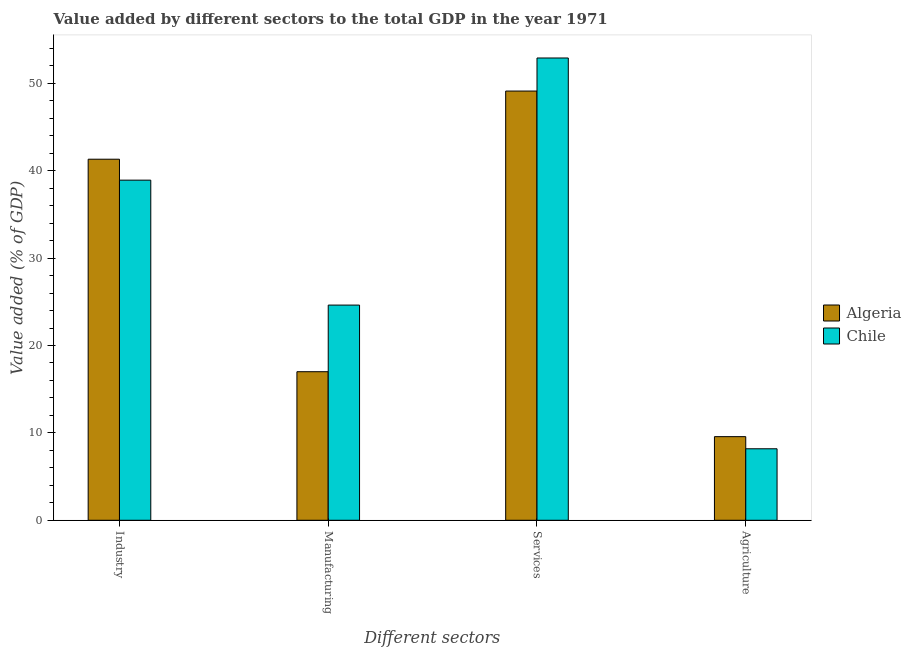How many groups of bars are there?
Ensure brevity in your answer.  4. Are the number of bars per tick equal to the number of legend labels?
Provide a succinct answer. Yes. What is the label of the 1st group of bars from the left?
Your response must be concise. Industry. What is the value added by agricultural sector in Chile?
Your response must be concise. 8.18. Across all countries, what is the maximum value added by manufacturing sector?
Offer a terse response. 24.62. Across all countries, what is the minimum value added by manufacturing sector?
Your answer should be compact. 17. In which country was the value added by industrial sector maximum?
Make the answer very short. Algeria. In which country was the value added by services sector minimum?
Your answer should be very brief. Algeria. What is the total value added by agricultural sector in the graph?
Your answer should be very brief. 17.75. What is the difference between the value added by agricultural sector in Chile and that in Algeria?
Make the answer very short. -1.39. What is the difference between the value added by services sector in Chile and the value added by agricultural sector in Algeria?
Give a very brief answer. 43.33. What is the average value added by industrial sector per country?
Ensure brevity in your answer.  40.12. What is the difference between the value added by services sector and value added by industrial sector in Chile?
Your answer should be very brief. 13.98. What is the ratio of the value added by industrial sector in Algeria to that in Chile?
Give a very brief answer. 1.06. What is the difference between the highest and the second highest value added by manufacturing sector?
Give a very brief answer. 7.62. What is the difference between the highest and the lowest value added by agricultural sector?
Provide a succinct answer. 1.39. In how many countries, is the value added by industrial sector greater than the average value added by industrial sector taken over all countries?
Your answer should be compact. 1. Is the sum of the value added by manufacturing sector in Chile and Algeria greater than the maximum value added by agricultural sector across all countries?
Your answer should be compact. Yes. What does the 1st bar from the left in Manufacturing represents?
Ensure brevity in your answer.  Algeria. What does the 1st bar from the right in Industry represents?
Keep it short and to the point. Chile. How many bars are there?
Offer a terse response. 8. How many countries are there in the graph?
Keep it short and to the point. 2. Does the graph contain grids?
Your answer should be compact. No. What is the title of the graph?
Keep it short and to the point. Value added by different sectors to the total GDP in the year 1971. Does "American Samoa" appear as one of the legend labels in the graph?
Offer a terse response. No. What is the label or title of the X-axis?
Make the answer very short. Different sectors. What is the label or title of the Y-axis?
Keep it short and to the point. Value added (% of GDP). What is the Value added (% of GDP) in Algeria in Industry?
Ensure brevity in your answer.  41.32. What is the Value added (% of GDP) of Chile in Industry?
Your response must be concise. 38.92. What is the Value added (% of GDP) in Algeria in Manufacturing?
Ensure brevity in your answer.  17. What is the Value added (% of GDP) in Chile in Manufacturing?
Offer a terse response. 24.62. What is the Value added (% of GDP) of Algeria in Services?
Keep it short and to the point. 49.12. What is the Value added (% of GDP) of Chile in Services?
Offer a terse response. 52.9. What is the Value added (% of GDP) in Algeria in Agriculture?
Your response must be concise. 9.57. What is the Value added (% of GDP) of Chile in Agriculture?
Your answer should be compact. 8.18. Across all Different sectors, what is the maximum Value added (% of GDP) in Algeria?
Provide a succinct answer. 49.12. Across all Different sectors, what is the maximum Value added (% of GDP) in Chile?
Keep it short and to the point. 52.9. Across all Different sectors, what is the minimum Value added (% of GDP) in Algeria?
Your response must be concise. 9.57. Across all Different sectors, what is the minimum Value added (% of GDP) in Chile?
Your answer should be very brief. 8.18. What is the total Value added (% of GDP) of Algeria in the graph?
Your answer should be very brief. 117. What is the total Value added (% of GDP) of Chile in the graph?
Provide a short and direct response. 124.62. What is the difference between the Value added (% of GDP) in Algeria in Industry and that in Manufacturing?
Your answer should be very brief. 24.32. What is the difference between the Value added (% of GDP) of Chile in Industry and that in Manufacturing?
Keep it short and to the point. 14.3. What is the difference between the Value added (% of GDP) of Algeria in Industry and that in Services?
Your answer should be compact. -7.8. What is the difference between the Value added (% of GDP) of Chile in Industry and that in Services?
Provide a succinct answer. -13.98. What is the difference between the Value added (% of GDP) in Algeria in Industry and that in Agriculture?
Your response must be concise. 31.75. What is the difference between the Value added (% of GDP) in Chile in Industry and that in Agriculture?
Offer a very short reply. 30.74. What is the difference between the Value added (% of GDP) in Algeria in Manufacturing and that in Services?
Offer a very short reply. -32.12. What is the difference between the Value added (% of GDP) in Chile in Manufacturing and that in Services?
Your response must be concise. -28.28. What is the difference between the Value added (% of GDP) of Algeria in Manufacturing and that in Agriculture?
Keep it short and to the point. 7.43. What is the difference between the Value added (% of GDP) in Chile in Manufacturing and that in Agriculture?
Provide a succinct answer. 16.44. What is the difference between the Value added (% of GDP) of Algeria in Services and that in Agriculture?
Offer a very short reply. 39.55. What is the difference between the Value added (% of GDP) in Chile in Services and that in Agriculture?
Offer a terse response. 44.72. What is the difference between the Value added (% of GDP) in Algeria in Industry and the Value added (% of GDP) in Chile in Manufacturing?
Your response must be concise. 16.69. What is the difference between the Value added (% of GDP) of Algeria in Industry and the Value added (% of GDP) of Chile in Services?
Offer a very short reply. -11.58. What is the difference between the Value added (% of GDP) in Algeria in Industry and the Value added (% of GDP) in Chile in Agriculture?
Provide a short and direct response. 33.13. What is the difference between the Value added (% of GDP) of Algeria in Manufacturing and the Value added (% of GDP) of Chile in Services?
Give a very brief answer. -35.9. What is the difference between the Value added (% of GDP) of Algeria in Manufacturing and the Value added (% of GDP) of Chile in Agriculture?
Offer a terse response. 8.82. What is the difference between the Value added (% of GDP) in Algeria in Services and the Value added (% of GDP) in Chile in Agriculture?
Your answer should be compact. 40.93. What is the average Value added (% of GDP) in Algeria per Different sectors?
Provide a short and direct response. 29.25. What is the average Value added (% of GDP) in Chile per Different sectors?
Your answer should be compact. 31.16. What is the difference between the Value added (% of GDP) in Algeria and Value added (% of GDP) in Chile in Industry?
Offer a very short reply. 2.4. What is the difference between the Value added (% of GDP) of Algeria and Value added (% of GDP) of Chile in Manufacturing?
Provide a succinct answer. -7.62. What is the difference between the Value added (% of GDP) in Algeria and Value added (% of GDP) in Chile in Services?
Give a very brief answer. -3.78. What is the difference between the Value added (% of GDP) in Algeria and Value added (% of GDP) in Chile in Agriculture?
Your answer should be very brief. 1.39. What is the ratio of the Value added (% of GDP) of Algeria in Industry to that in Manufacturing?
Provide a short and direct response. 2.43. What is the ratio of the Value added (% of GDP) of Chile in Industry to that in Manufacturing?
Offer a very short reply. 1.58. What is the ratio of the Value added (% of GDP) of Algeria in Industry to that in Services?
Provide a succinct answer. 0.84. What is the ratio of the Value added (% of GDP) in Chile in Industry to that in Services?
Your answer should be compact. 0.74. What is the ratio of the Value added (% of GDP) of Algeria in Industry to that in Agriculture?
Your answer should be very brief. 4.32. What is the ratio of the Value added (% of GDP) of Chile in Industry to that in Agriculture?
Keep it short and to the point. 4.76. What is the ratio of the Value added (% of GDP) in Algeria in Manufacturing to that in Services?
Keep it short and to the point. 0.35. What is the ratio of the Value added (% of GDP) in Chile in Manufacturing to that in Services?
Your response must be concise. 0.47. What is the ratio of the Value added (% of GDP) in Algeria in Manufacturing to that in Agriculture?
Your response must be concise. 1.78. What is the ratio of the Value added (% of GDP) in Chile in Manufacturing to that in Agriculture?
Keep it short and to the point. 3.01. What is the ratio of the Value added (% of GDP) in Algeria in Services to that in Agriculture?
Ensure brevity in your answer.  5.13. What is the ratio of the Value added (% of GDP) of Chile in Services to that in Agriculture?
Keep it short and to the point. 6.47. What is the difference between the highest and the second highest Value added (% of GDP) in Algeria?
Offer a terse response. 7.8. What is the difference between the highest and the second highest Value added (% of GDP) in Chile?
Offer a very short reply. 13.98. What is the difference between the highest and the lowest Value added (% of GDP) in Algeria?
Keep it short and to the point. 39.55. What is the difference between the highest and the lowest Value added (% of GDP) in Chile?
Offer a very short reply. 44.72. 